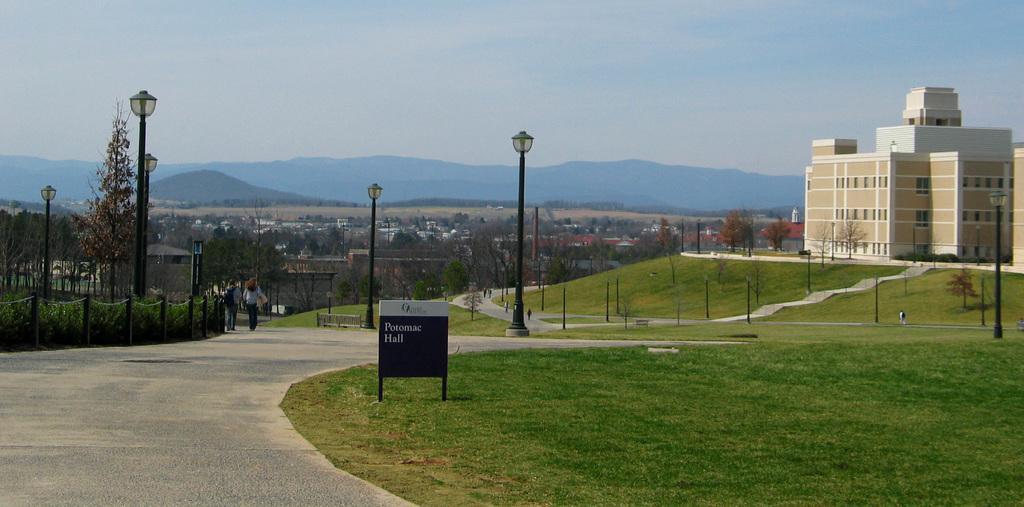Can you describe this image briefly? In the given image i can see a buildings with windows,light poles,plants,fence,trees,people,grass,board,mountains and in the background i can see the sky. 